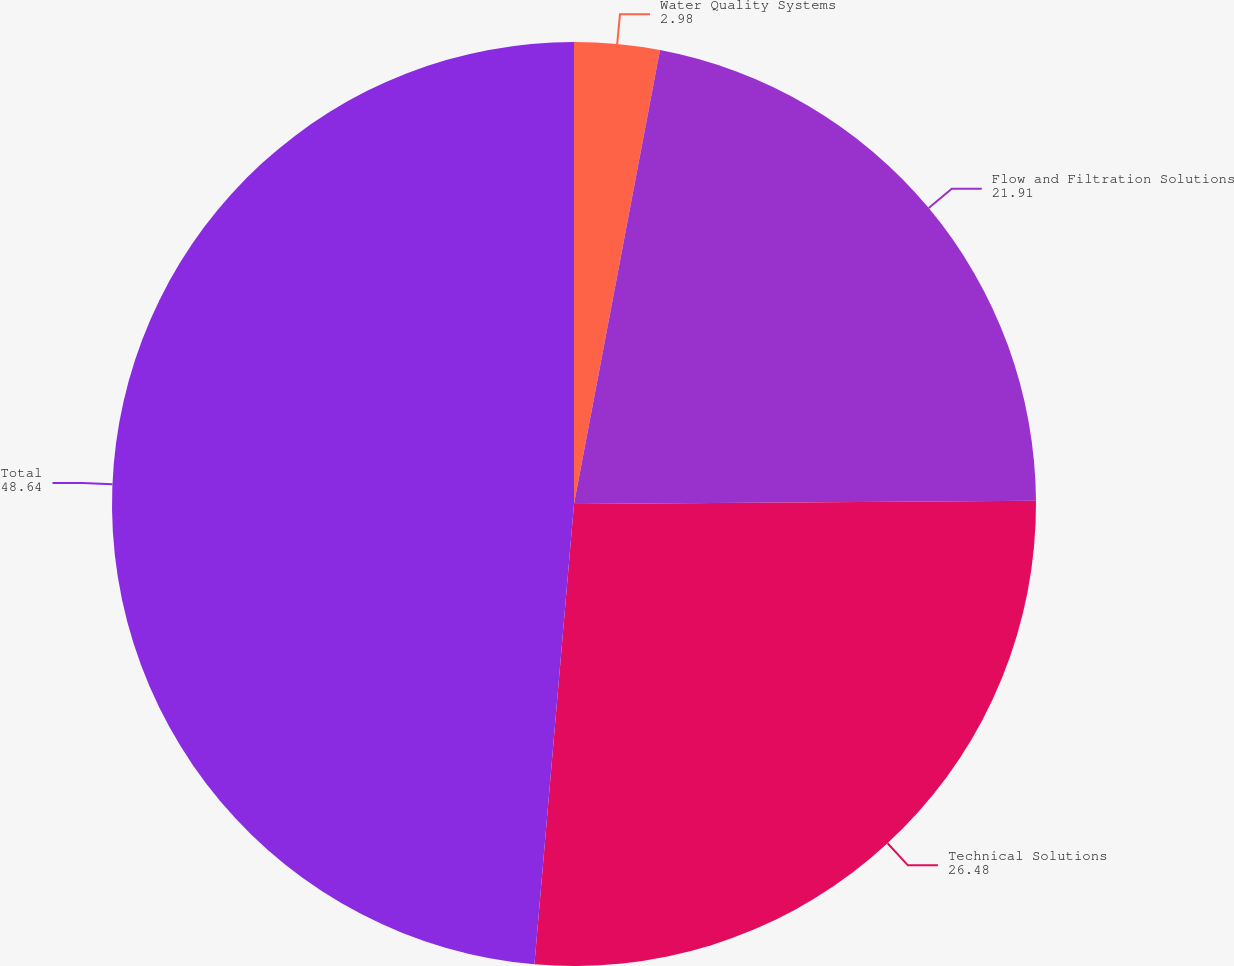Convert chart to OTSL. <chart><loc_0><loc_0><loc_500><loc_500><pie_chart><fcel>Water Quality Systems<fcel>Flow and Filtration Solutions<fcel>Technical Solutions<fcel>Total<nl><fcel>2.98%<fcel>21.91%<fcel>26.48%<fcel>48.64%<nl></chart> 